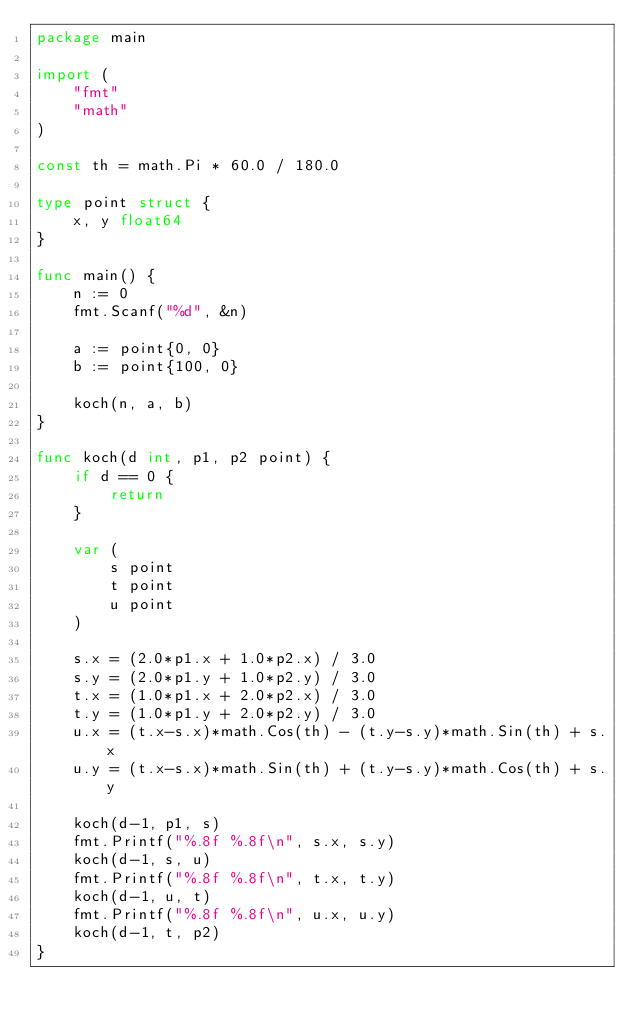<code> <loc_0><loc_0><loc_500><loc_500><_Go_>package main

import (
	"fmt"
	"math"
)

const th = math.Pi * 60.0 / 180.0

type point struct {
	x, y float64
}

func main() {
	n := 0
	fmt.Scanf("%d", &n)

	a := point{0, 0}
	b := point{100, 0}

	koch(n, a, b)
}

func koch(d int, p1, p2 point) {
	if d == 0 {
		return
	}

	var (
		s point
		t point
		u point
	)

	s.x = (2.0*p1.x + 1.0*p2.x) / 3.0
	s.y = (2.0*p1.y + 1.0*p2.y) / 3.0
	t.x = (1.0*p1.x + 2.0*p2.x) / 3.0
	t.y = (1.0*p1.y + 2.0*p2.y) / 3.0
	u.x = (t.x-s.x)*math.Cos(th) - (t.y-s.y)*math.Sin(th) + s.x
	u.y = (t.x-s.x)*math.Sin(th) + (t.y-s.y)*math.Cos(th) + s.y

	koch(d-1, p1, s)
	fmt.Printf("%.8f %.8f\n", s.x, s.y)
	koch(d-1, s, u)
	fmt.Printf("%.8f %.8f\n", t.x, t.y)
	koch(d-1, u, t)
	fmt.Printf("%.8f %.8f\n", u.x, u.y)
	koch(d-1, t, p2)
}

</code> 